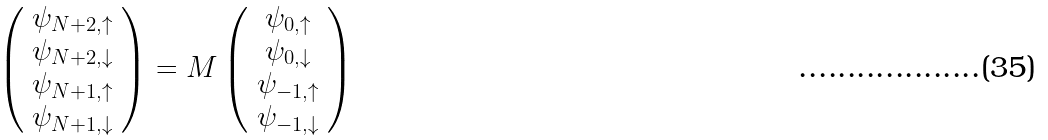<formula> <loc_0><loc_0><loc_500><loc_500>\left ( \begin{array} { c } \psi _ { N + 2 , \uparrow } \\ \psi _ { N + 2 , \downarrow } \\ \psi _ { N + 1 , \uparrow } \\ \psi _ { N + 1 , \downarrow } \end{array} \right ) = M \left ( \begin{array} { c } \psi _ { 0 , \uparrow } \\ \psi _ { 0 , \downarrow } \\ \psi _ { - 1 , \uparrow } \\ \psi _ { - 1 , \downarrow } \end{array} \right )</formula> 